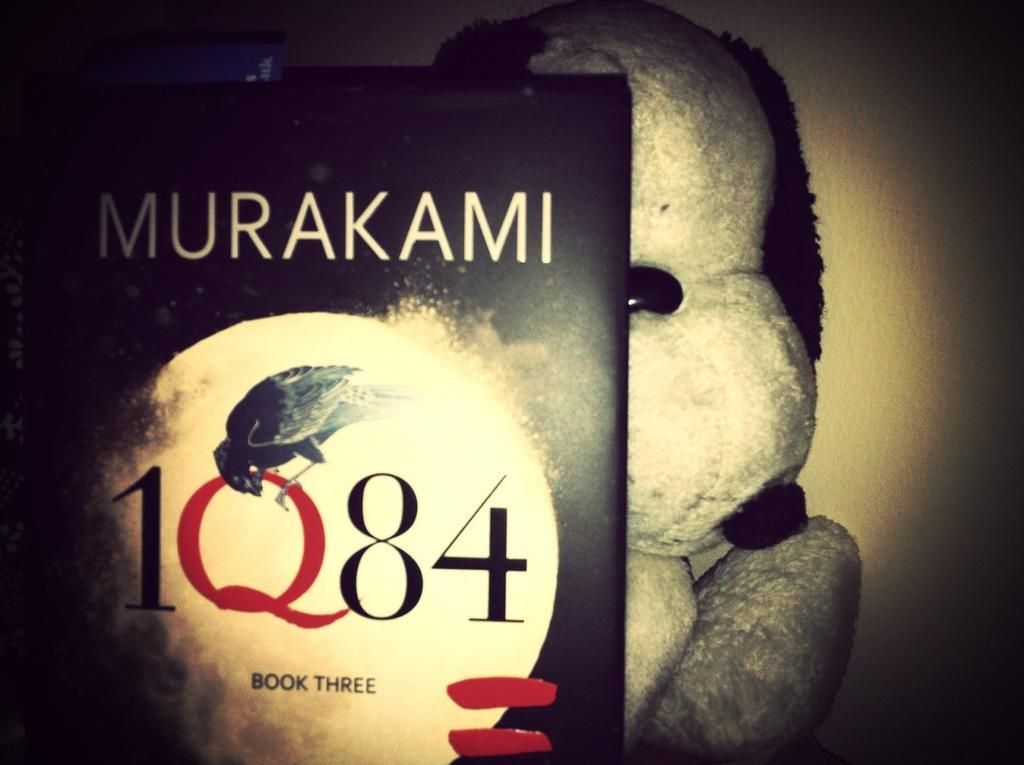<image>
Provide a brief description of the given image. A book by Murakami, 1Q84 Book Three, resting on the left half of a stuffed dog. 